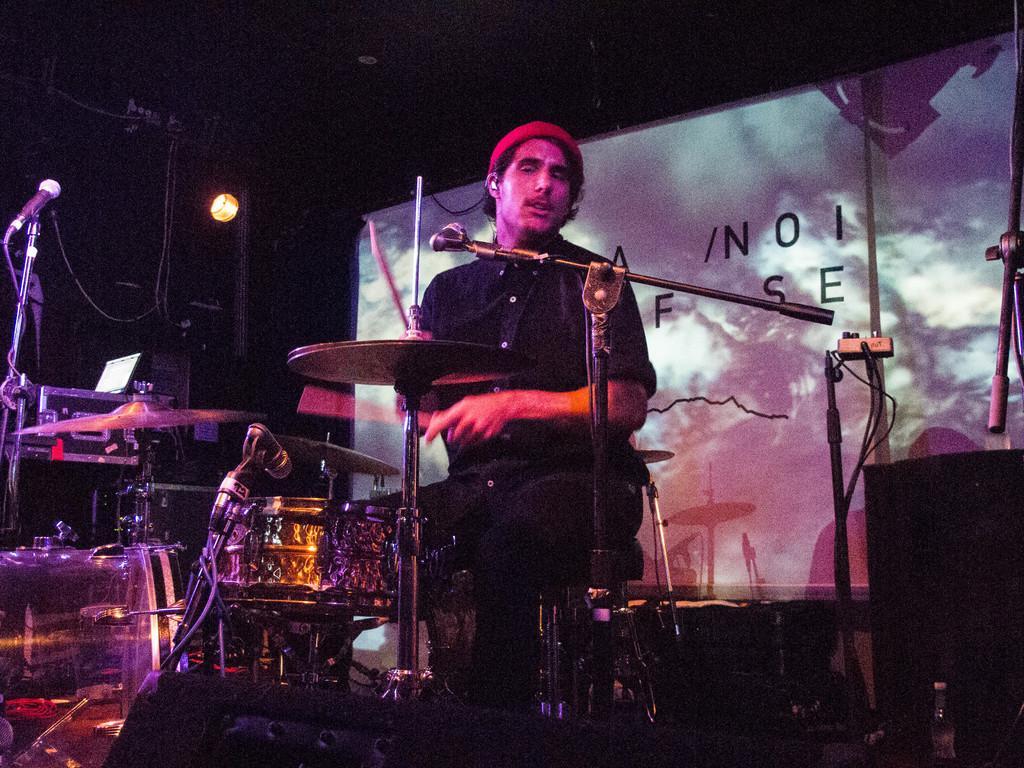Describe this image in one or two sentences. In the image there are many musical instruments and also there are stands with mics. In the middle of them there is a man sitting. And also there are speakers. Behind them there is a screen and also there is a black background. 